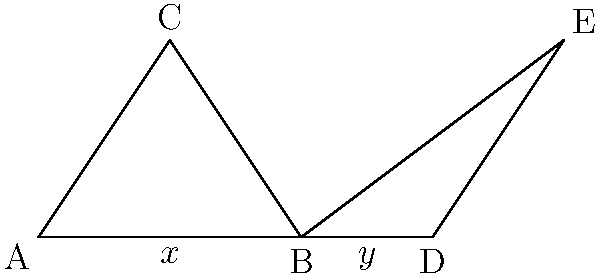In the diagram above, $\triangle ABC$ and $\triangle BDE$ share side $\overline{BD}$. If $\angle ABC = \angle DBE$, $x = 4$ cm, and $y = 2$ cm, what additional information is needed to prove that $\triangle ABC \cong \triangle BDE$ using the SAS postulate? To prove congruence using the Side-Angle-Side (SAS) postulate, we need to establish that two sides and the included angle of one triangle are congruent to the corresponding parts of the other triangle. Let's break down the given information and what we need:

1. We know that $\angle ABC = \angle DBE$ (given in the question).
2. We have information about side $\overline{AB}$ ($x = 4$ cm) and side $\overline{BD}$ ($y = 2$ cm).

For SAS, we need:
a) Two pairs of congruent sides
b) The included angles between these sides to be congruent

We already have one pair of congruent angles. We need to establish that:
1. $\overline{AB} \cong \overline{BD}$ (we have this information)
2. Another pair of corresponding sides is congruent

Since we know $\overline{AB}$ and $\overline{BD}$, the additional information we need is the length of either $\overline{BC}$ or $\overline{DE}$. If we know that $\overline{BC} \cong \overline{DE}$, we can use SAS to prove the triangles are congruent.
Answer: Length of $\overline{BC}$ or $\overline{DE}$ 